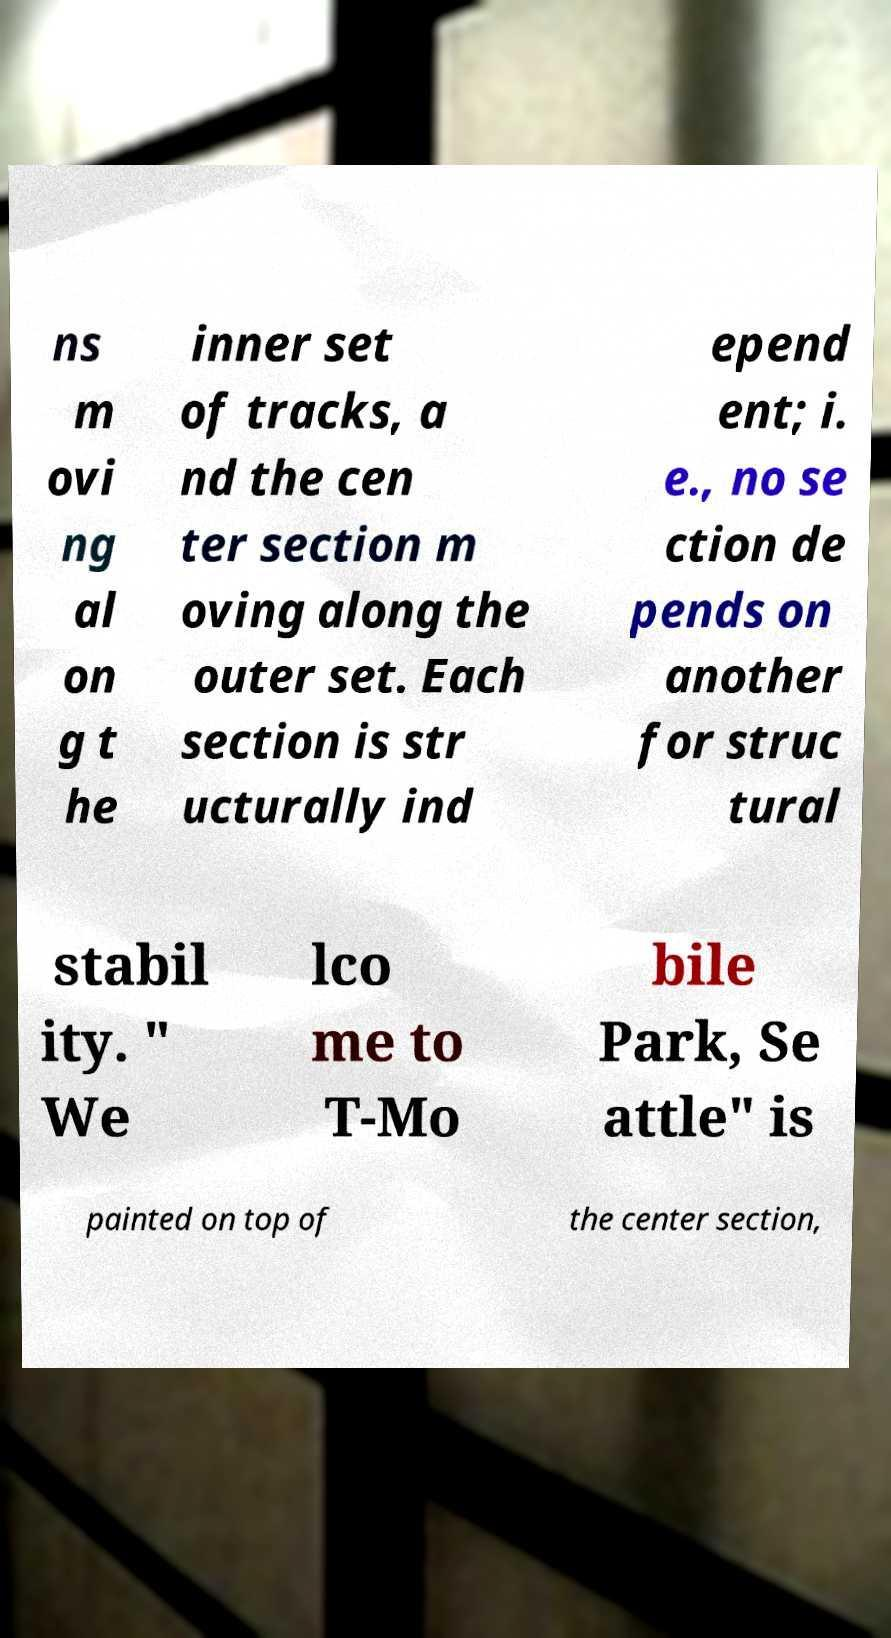For documentation purposes, I need the text within this image transcribed. Could you provide that? ns m ovi ng al on g t he inner set of tracks, a nd the cen ter section m oving along the outer set. Each section is str ucturally ind epend ent; i. e., no se ction de pends on another for struc tural stabil ity. " We lco me to T-Mo bile Park, Se attle" is painted on top of the center section, 